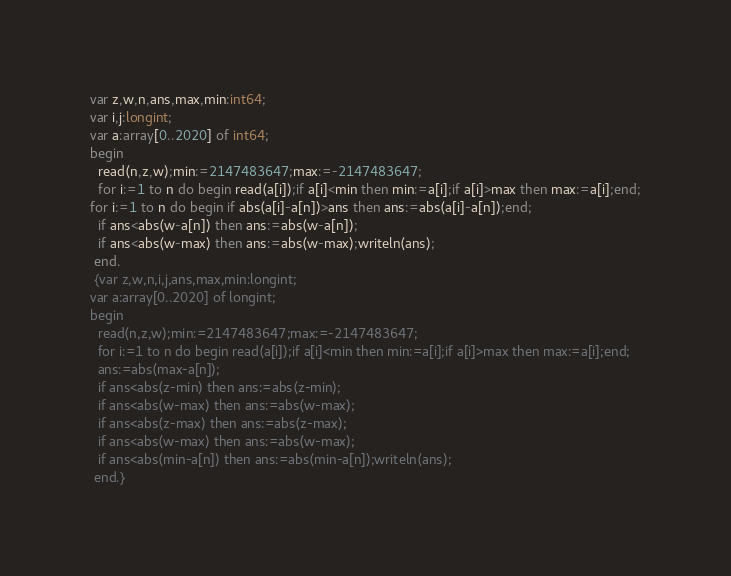<code> <loc_0><loc_0><loc_500><loc_500><_Pascal_>var z,w,n,ans,max,min:int64;
var i,j:longint;
var a:array[0..2020] of int64;
begin 
  read(n,z,w);min:=2147483647;max:=-2147483647;
  for i:=1 to n do begin read(a[i]);if a[i]<min then min:=a[i];if a[i]>max then max:=a[i];end;
for i:=1 to n do begin if abs(a[i]-a[n])>ans then ans:=abs(a[i]-a[n]);end;
  if ans<abs(w-a[n]) then ans:=abs(w-a[n]);
  if ans<abs(w-max) then ans:=abs(w-max);writeln(ans);
 end.
 {var z,w,n,i,j,ans,max,min:longint;
var a:array[0..2020] of longint;
begin 
  read(n,z,w);min:=2147483647;max:=-2147483647;
  for i:=1 to n do begin read(a[i]);if a[i]<min then min:=a[i];if a[i]>max then max:=a[i];end;
  ans:=abs(max-a[n]);
  if ans<abs(z-min) then ans:=abs(z-min);
  if ans<abs(w-max) then ans:=abs(w-max);
  if ans<abs(z-max) then ans:=abs(z-max);
  if ans<abs(w-max) then ans:=abs(w-max);
  if ans<abs(min-a[n]) then ans:=abs(min-a[n]);writeln(ans);
 end.}</code> 